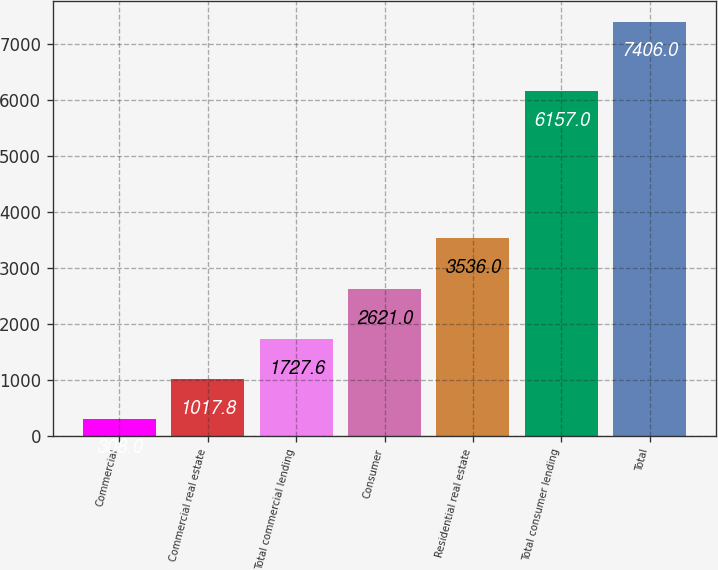Convert chart. <chart><loc_0><loc_0><loc_500><loc_500><bar_chart><fcel>Commercial<fcel>Commercial real estate<fcel>Total commercial lending<fcel>Consumer<fcel>Residential real estate<fcel>Total consumer lending<fcel>Total<nl><fcel>308<fcel>1017.8<fcel>1727.6<fcel>2621<fcel>3536<fcel>6157<fcel>7406<nl></chart> 